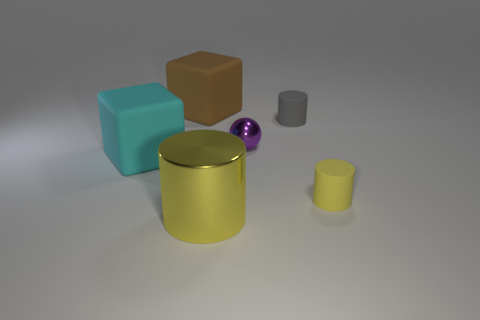What is the color of the other rubber object that is the same size as the gray thing? The color of the cylindrical rubber object that is comparable in size to the gray cylinder is yellow. Its vibrant hue contrasts nicely with the more muted colors of the other objects in the scene. 